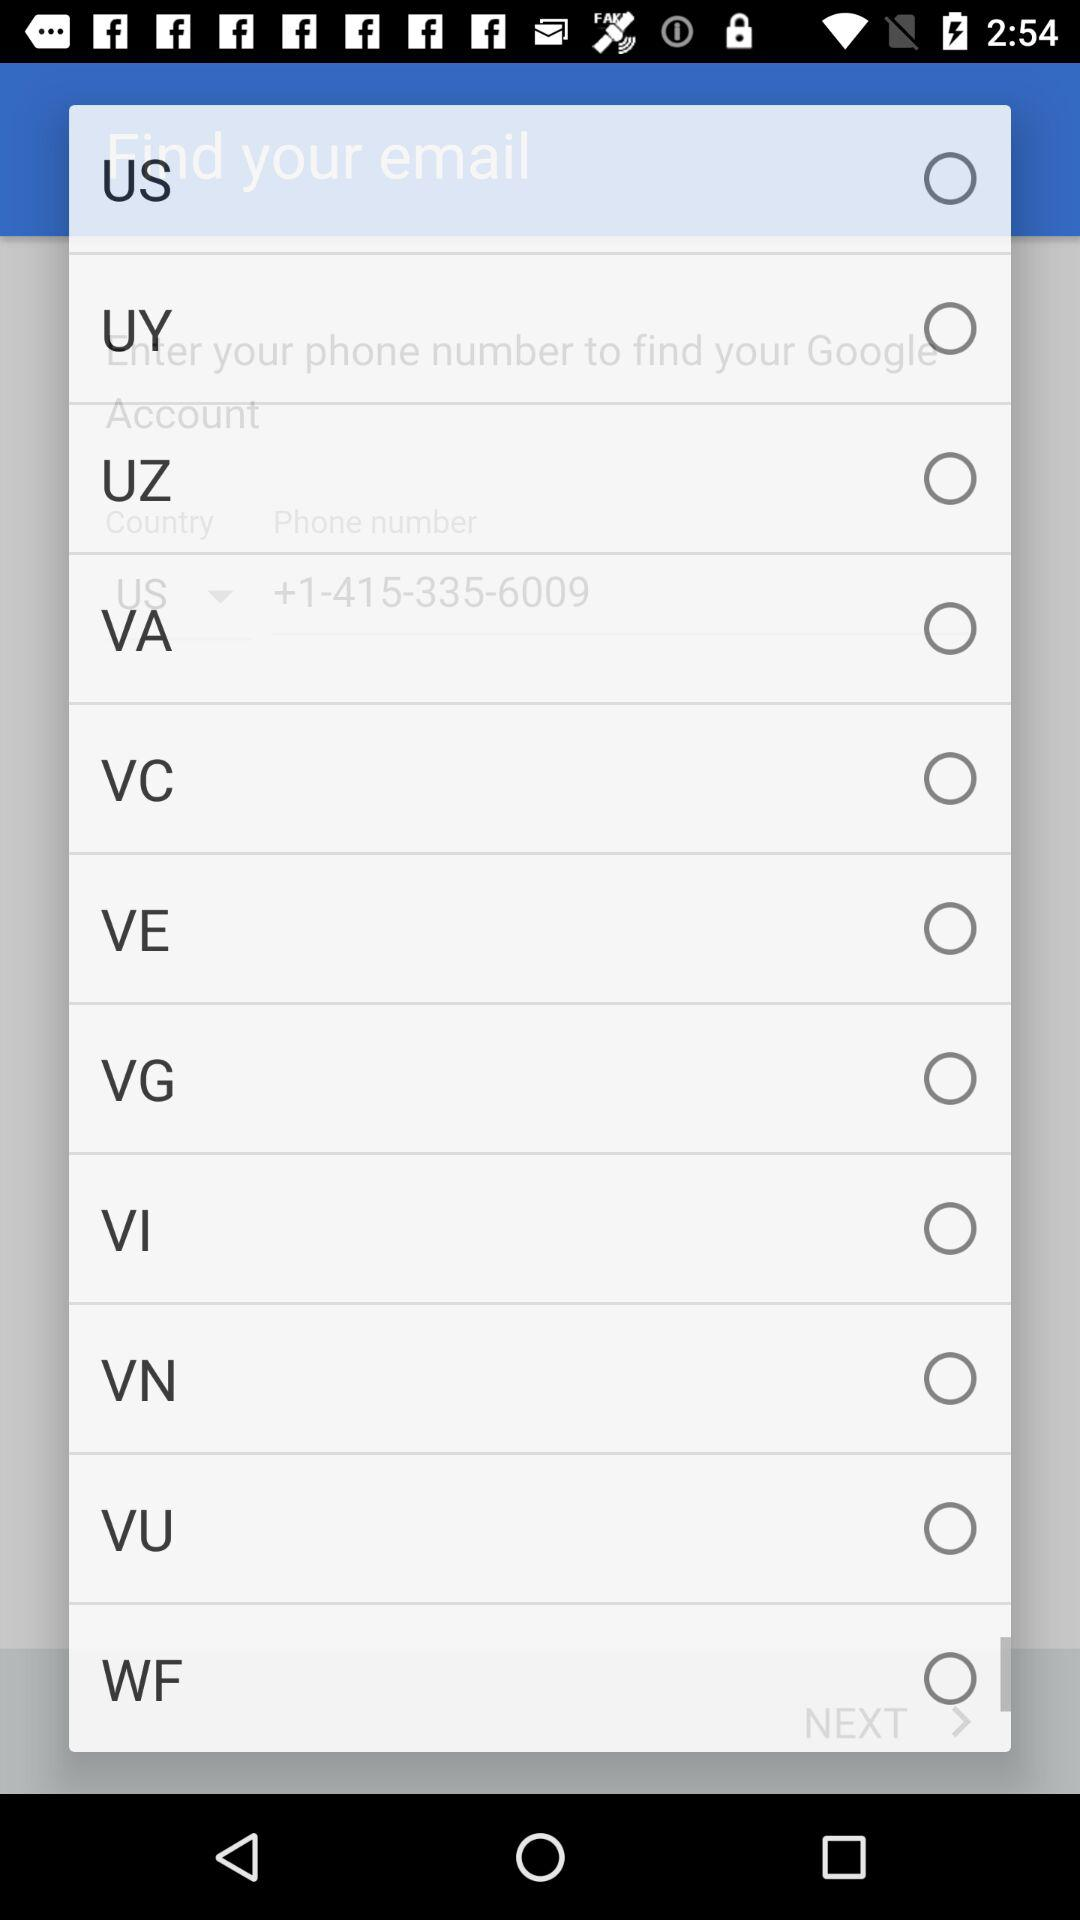Is the "WF" radio button selected or not? The "WF" radio button is not selected. 